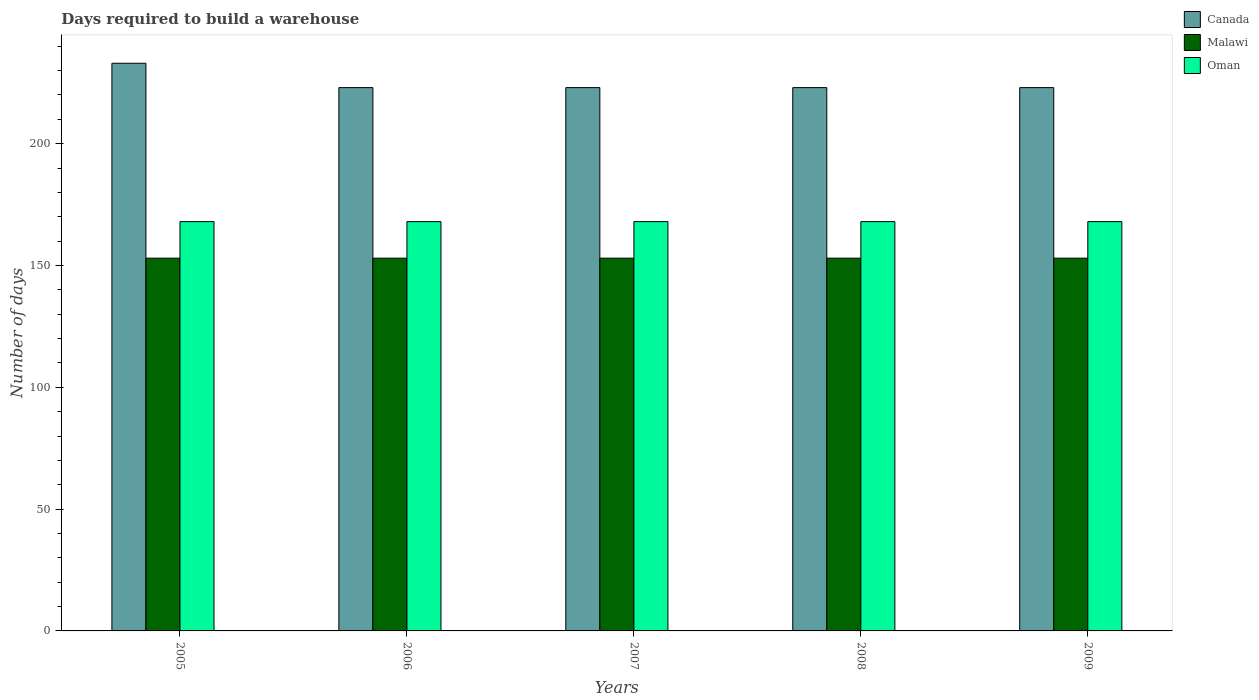How many different coloured bars are there?
Make the answer very short. 3. How many groups of bars are there?
Your response must be concise. 5. Are the number of bars per tick equal to the number of legend labels?
Provide a succinct answer. Yes. How many bars are there on the 4th tick from the right?
Keep it short and to the point. 3. In how many cases, is the number of bars for a given year not equal to the number of legend labels?
Offer a very short reply. 0. What is the days required to build a warehouse in in Malawi in 2008?
Make the answer very short. 153. Across all years, what is the maximum days required to build a warehouse in in Oman?
Ensure brevity in your answer.  168. Across all years, what is the minimum days required to build a warehouse in in Oman?
Offer a terse response. 168. In which year was the days required to build a warehouse in in Oman maximum?
Your answer should be very brief. 2005. What is the total days required to build a warehouse in in Oman in the graph?
Ensure brevity in your answer.  840. What is the difference between the days required to build a warehouse in in Oman in 2007 and the days required to build a warehouse in in Malawi in 2008?
Your answer should be very brief. 15. What is the average days required to build a warehouse in in Malawi per year?
Your answer should be very brief. 153. In the year 2008, what is the difference between the days required to build a warehouse in in Canada and days required to build a warehouse in in Oman?
Give a very brief answer. 55. What is the ratio of the days required to build a warehouse in in Canada in 2005 to that in 2009?
Your answer should be very brief. 1.04. What is the difference between the highest and the second highest days required to build a warehouse in in Oman?
Offer a very short reply. 0. What is the difference between the highest and the lowest days required to build a warehouse in in Canada?
Offer a terse response. 10. What does the 3rd bar from the left in 2008 represents?
Your answer should be compact. Oman. What does the 1st bar from the right in 2005 represents?
Offer a very short reply. Oman. Is it the case that in every year, the sum of the days required to build a warehouse in in Canada and days required to build a warehouse in in Oman is greater than the days required to build a warehouse in in Malawi?
Give a very brief answer. Yes. How many bars are there?
Make the answer very short. 15. Are all the bars in the graph horizontal?
Offer a very short reply. No. How many years are there in the graph?
Your answer should be compact. 5. Are the values on the major ticks of Y-axis written in scientific E-notation?
Offer a terse response. No. Does the graph contain any zero values?
Keep it short and to the point. No. Where does the legend appear in the graph?
Make the answer very short. Top right. How many legend labels are there?
Make the answer very short. 3. How are the legend labels stacked?
Offer a terse response. Vertical. What is the title of the graph?
Offer a terse response. Days required to build a warehouse. Does "Bolivia" appear as one of the legend labels in the graph?
Provide a short and direct response. No. What is the label or title of the Y-axis?
Make the answer very short. Number of days. What is the Number of days of Canada in 2005?
Give a very brief answer. 233. What is the Number of days of Malawi in 2005?
Provide a short and direct response. 153. What is the Number of days of Oman in 2005?
Give a very brief answer. 168. What is the Number of days in Canada in 2006?
Make the answer very short. 223. What is the Number of days of Malawi in 2006?
Provide a short and direct response. 153. What is the Number of days of Oman in 2006?
Your answer should be very brief. 168. What is the Number of days in Canada in 2007?
Your response must be concise. 223. What is the Number of days of Malawi in 2007?
Ensure brevity in your answer.  153. What is the Number of days in Oman in 2007?
Ensure brevity in your answer.  168. What is the Number of days of Canada in 2008?
Ensure brevity in your answer.  223. What is the Number of days of Malawi in 2008?
Keep it short and to the point. 153. What is the Number of days of Oman in 2008?
Offer a terse response. 168. What is the Number of days in Canada in 2009?
Make the answer very short. 223. What is the Number of days in Malawi in 2009?
Offer a very short reply. 153. What is the Number of days of Oman in 2009?
Your response must be concise. 168. Across all years, what is the maximum Number of days in Canada?
Provide a succinct answer. 233. Across all years, what is the maximum Number of days in Malawi?
Offer a terse response. 153. Across all years, what is the maximum Number of days in Oman?
Provide a succinct answer. 168. Across all years, what is the minimum Number of days of Canada?
Make the answer very short. 223. Across all years, what is the minimum Number of days of Malawi?
Ensure brevity in your answer.  153. Across all years, what is the minimum Number of days of Oman?
Give a very brief answer. 168. What is the total Number of days of Canada in the graph?
Ensure brevity in your answer.  1125. What is the total Number of days of Malawi in the graph?
Provide a short and direct response. 765. What is the total Number of days of Oman in the graph?
Offer a very short reply. 840. What is the difference between the Number of days in Canada in 2005 and that in 2006?
Give a very brief answer. 10. What is the difference between the Number of days in Canada in 2005 and that in 2007?
Your answer should be very brief. 10. What is the difference between the Number of days in Malawi in 2005 and that in 2007?
Offer a terse response. 0. What is the difference between the Number of days in Oman in 2005 and that in 2009?
Keep it short and to the point. 0. What is the difference between the Number of days in Canada in 2006 and that in 2008?
Ensure brevity in your answer.  0. What is the difference between the Number of days in Malawi in 2006 and that in 2008?
Provide a succinct answer. 0. What is the difference between the Number of days of Oman in 2006 and that in 2009?
Your response must be concise. 0. What is the difference between the Number of days in Canada in 2007 and that in 2008?
Give a very brief answer. 0. What is the difference between the Number of days in Malawi in 2007 and that in 2009?
Make the answer very short. 0. What is the difference between the Number of days in Oman in 2007 and that in 2009?
Your answer should be compact. 0. What is the difference between the Number of days in Canada in 2005 and the Number of days in Oman in 2006?
Provide a succinct answer. 65. What is the difference between the Number of days in Malawi in 2005 and the Number of days in Oman in 2006?
Provide a succinct answer. -15. What is the difference between the Number of days of Malawi in 2005 and the Number of days of Oman in 2007?
Make the answer very short. -15. What is the difference between the Number of days of Canada in 2005 and the Number of days of Malawi in 2008?
Your answer should be very brief. 80. What is the difference between the Number of days in Canada in 2005 and the Number of days in Oman in 2008?
Give a very brief answer. 65. What is the difference between the Number of days of Canada in 2005 and the Number of days of Oman in 2009?
Ensure brevity in your answer.  65. What is the difference between the Number of days of Malawi in 2005 and the Number of days of Oman in 2009?
Give a very brief answer. -15. What is the difference between the Number of days of Canada in 2006 and the Number of days of Malawi in 2007?
Provide a succinct answer. 70. What is the difference between the Number of days of Canada in 2006 and the Number of days of Oman in 2007?
Your answer should be very brief. 55. What is the difference between the Number of days of Canada in 2006 and the Number of days of Oman in 2008?
Offer a very short reply. 55. What is the difference between the Number of days in Canada in 2006 and the Number of days in Malawi in 2009?
Give a very brief answer. 70. What is the difference between the Number of days in Canada in 2006 and the Number of days in Oman in 2009?
Your answer should be very brief. 55. What is the difference between the Number of days of Malawi in 2006 and the Number of days of Oman in 2009?
Provide a short and direct response. -15. What is the difference between the Number of days in Canada in 2007 and the Number of days in Oman in 2008?
Provide a short and direct response. 55. What is the difference between the Number of days of Malawi in 2007 and the Number of days of Oman in 2008?
Provide a short and direct response. -15. What is the difference between the Number of days in Malawi in 2007 and the Number of days in Oman in 2009?
Your answer should be compact. -15. What is the difference between the Number of days in Canada in 2008 and the Number of days in Malawi in 2009?
Provide a succinct answer. 70. What is the average Number of days of Canada per year?
Give a very brief answer. 225. What is the average Number of days of Malawi per year?
Your response must be concise. 153. What is the average Number of days of Oman per year?
Provide a succinct answer. 168. In the year 2005, what is the difference between the Number of days in Canada and Number of days in Malawi?
Offer a very short reply. 80. In the year 2005, what is the difference between the Number of days of Canada and Number of days of Oman?
Give a very brief answer. 65. In the year 2005, what is the difference between the Number of days in Malawi and Number of days in Oman?
Give a very brief answer. -15. In the year 2006, what is the difference between the Number of days in Canada and Number of days in Malawi?
Offer a very short reply. 70. In the year 2006, what is the difference between the Number of days in Canada and Number of days in Oman?
Your response must be concise. 55. In the year 2007, what is the difference between the Number of days in Canada and Number of days in Malawi?
Give a very brief answer. 70. In the year 2007, what is the difference between the Number of days in Malawi and Number of days in Oman?
Your response must be concise. -15. In the year 2008, what is the difference between the Number of days of Canada and Number of days of Malawi?
Offer a very short reply. 70. In the year 2008, what is the difference between the Number of days of Canada and Number of days of Oman?
Provide a short and direct response. 55. In the year 2008, what is the difference between the Number of days in Malawi and Number of days in Oman?
Your answer should be very brief. -15. In the year 2009, what is the difference between the Number of days in Canada and Number of days in Malawi?
Ensure brevity in your answer.  70. What is the ratio of the Number of days of Canada in 2005 to that in 2006?
Provide a short and direct response. 1.04. What is the ratio of the Number of days in Malawi in 2005 to that in 2006?
Keep it short and to the point. 1. What is the ratio of the Number of days in Canada in 2005 to that in 2007?
Your response must be concise. 1.04. What is the ratio of the Number of days in Malawi in 2005 to that in 2007?
Make the answer very short. 1. What is the ratio of the Number of days in Oman in 2005 to that in 2007?
Your answer should be very brief. 1. What is the ratio of the Number of days of Canada in 2005 to that in 2008?
Keep it short and to the point. 1.04. What is the ratio of the Number of days in Malawi in 2005 to that in 2008?
Your response must be concise. 1. What is the ratio of the Number of days in Oman in 2005 to that in 2008?
Give a very brief answer. 1. What is the ratio of the Number of days of Canada in 2005 to that in 2009?
Offer a very short reply. 1.04. What is the ratio of the Number of days of Malawi in 2005 to that in 2009?
Keep it short and to the point. 1. What is the ratio of the Number of days in Oman in 2006 to that in 2007?
Your answer should be compact. 1. What is the ratio of the Number of days of Canada in 2006 to that in 2008?
Give a very brief answer. 1. What is the ratio of the Number of days of Malawi in 2006 to that in 2009?
Your answer should be compact. 1. What is the ratio of the Number of days in Canada in 2007 to that in 2008?
Ensure brevity in your answer.  1. What is the ratio of the Number of days of Malawi in 2007 to that in 2008?
Your answer should be very brief. 1. What is the ratio of the Number of days of Oman in 2007 to that in 2008?
Provide a succinct answer. 1. What is the ratio of the Number of days of Oman in 2007 to that in 2009?
Your response must be concise. 1. What is the ratio of the Number of days of Oman in 2008 to that in 2009?
Offer a terse response. 1. What is the difference between the highest and the second highest Number of days in Canada?
Offer a very short reply. 10. What is the difference between the highest and the second highest Number of days of Malawi?
Offer a very short reply. 0. What is the difference between the highest and the second highest Number of days in Oman?
Your response must be concise. 0. What is the difference between the highest and the lowest Number of days in Canada?
Give a very brief answer. 10. What is the difference between the highest and the lowest Number of days in Malawi?
Provide a succinct answer. 0. What is the difference between the highest and the lowest Number of days of Oman?
Offer a terse response. 0. 